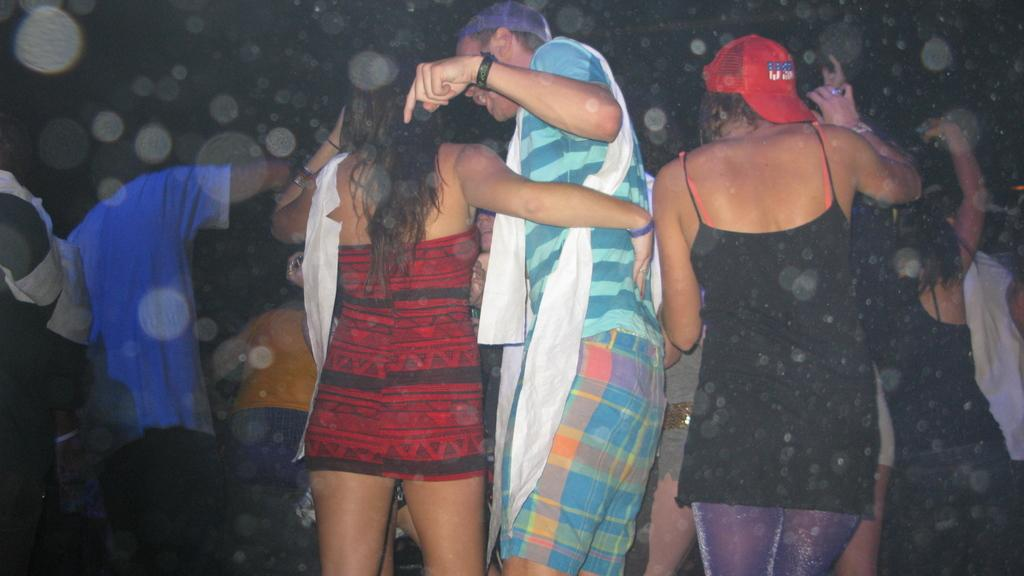How many people are in the image? There is a group of people in the image. What are the people in the image doing? The people are standing. What can be observed about the background of the image? The background of the image is dark. What type of loaf can be seen floating in the stream in the image? There is no loaf or stream present in the image; it features a group of people standing in front of a dark background. 